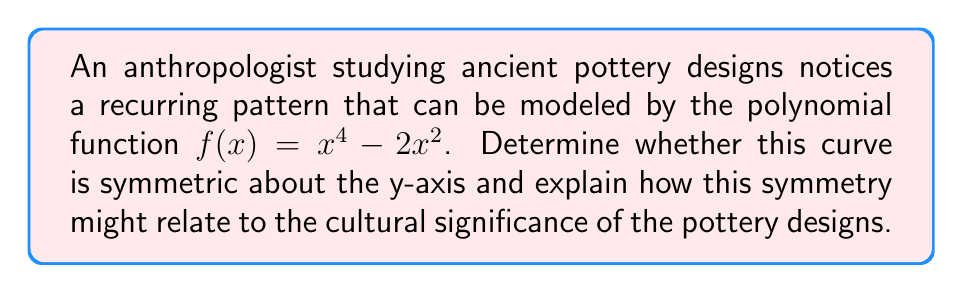Can you solve this math problem? To determine if the polynomial $f(x) = x^4 - 2x^2$ is symmetric about the y-axis, we need to check if $f(x) = f(-x)$ for all x.

Step 1: Replace x with -x in the original function.
$f(-x) = (-x)^4 - 2(-x)^2$

Step 2: Simplify the expression.
$f(-x) = x^4 - 2x^2$
This is because $(-x)^4 = x^4$ (even power) and $(-x)^2 = x^2$.

Step 3: Compare $f(x)$ and $f(-x)$.
$f(x) = x^4 - 2x^2$
$f(-x) = x^4 - 2x^2$

We can see that $f(x) = f(-x)$, which means the function is symmetric about the y-axis.

Cultural significance:
This symmetry in the polynomial curve suggests that the ancient pottery designs have a balanced, mirror-like quality when viewed from the center. In many cultures, symmetry in art and design often represents concepts such as harmony, balance, or perfection. The use of a symmetric pattern might indicate that these values were important in the culture that produced these pottery designs.

Additionally, the specific shape of this polynomial (with two dips on either side of the y-axis) could represent recurring motifs in the pottery, such as stylized waves, mountains, or other natural forms that held significance for the ancient artisans.
Answer: Yes, symmetric about y-axis; $f(x) = f(-x)$ 